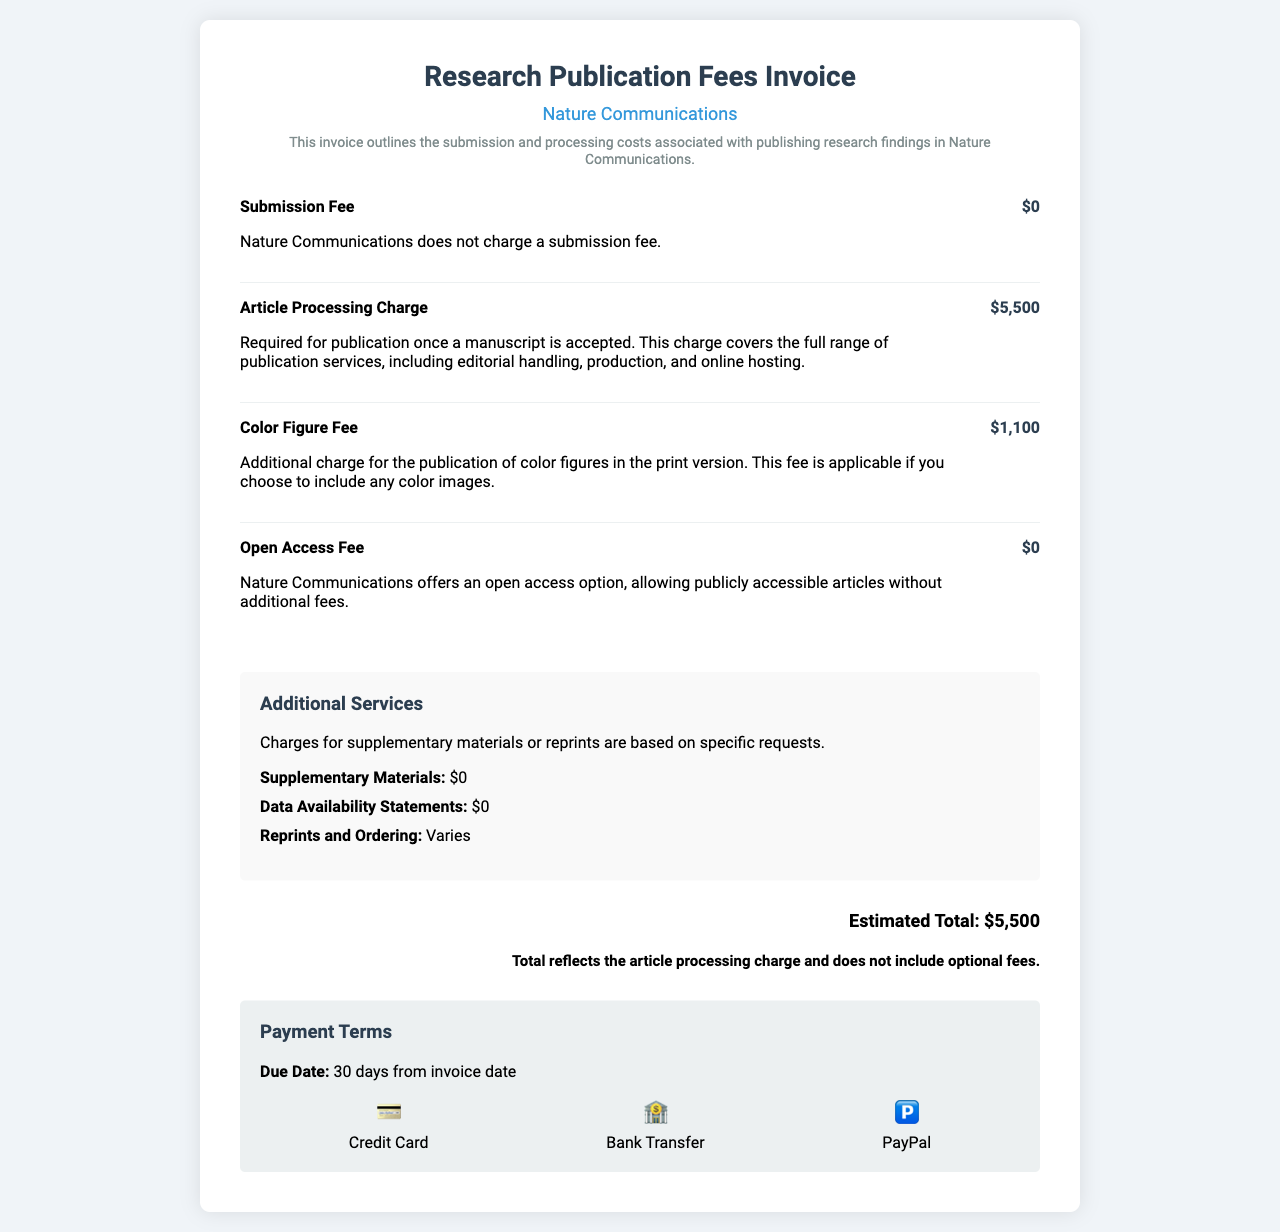what is the submission fee? The document states that Nature Communications does not charge a submission fee, making it $0.
Answer: $0 what is the article processing charge? The article processing charge required for publication is detailed as $5,500 in the document.
Answer: $5,500 what is the color figure fee? The document mentions an additional charge of $1,100 for the publication of color figures.
Answer: $1,100 are there any additional charges for supplementary materials? The invoice indicates that supplementary materials are charged at $0.
Answer: $0 what is the estimated total cost? The total cost, which reflects the article processing charge and excludes optional fees, is given as $5,500.
Answer: $5,500 what is the due date for payment? According to the document, the due date for payment is specified as 30 days from the invoice date.
Answer: 30 days which payment method offers credit card options? The invoice provides a payment method highlighting the use of credit cards.
Answer: Credit Card does Nature Communications charge for open access? The document explicitly states that Nature Communications offers an open access option with no additional fees.
Answer: No 